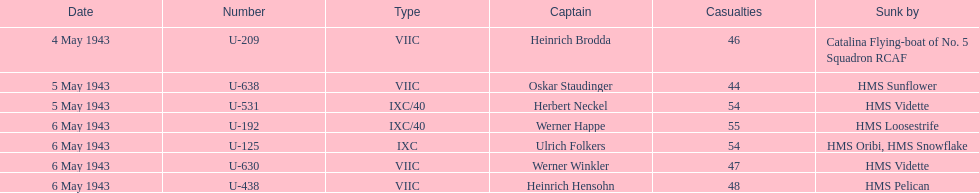What vessels were lost on may 5? U-638, U-531. Who were the commanders of those vessels? Oskar Staudinger, Herbert Neckel. Could you parse the entire table? {'header': ['Date', 'Number', 'Type', 'Captain', 'Casualties', 'Sunk by'], 'rows': [['4 May 1943', 'U-209', 'VIIC', 'Heinrich Brodda', '46', 'Catalina Flying-boat of No. 5 Squadron RCAF'], ['5 May 1943', 'U-638', 'VIIC', 'Oskar Staudinger', '44', 'HMS Sunflower'], ['5 May 1943', 'U-531', 'IXC/40', 'Herbert Neckel', '54', 'HMS Vidette'], ['6 May 1943', 'U-192', 'IXC/40', 'Werner Happe', '55', 'HMS Loosestrife'], ['6 May 1943', 'U-125', 'IXC', 'Ulrich Folkers', '54', 'HMS Oribi, HMS Snowflake'], ['6 May 1943', 'U-630', 'VIIC', 'Werner Winkler', '47', 'HMS Vidette'], ['6 May 1943', 'U-438', 'VIIC', 'Heinrich Hensohn', '48', 'HMS Pelican']]} Which commander was not oskar staudinger? Herbert Neckel. 